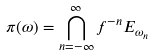Convert formula to latex. <formula><loc_0><loc_0><loc_500><loc_500>\pi ( \omega ) = \bigcap _ { n = - \infty } ^ { \infty } f ^ { - n } E _ { \omega _ { n } }</formula> 